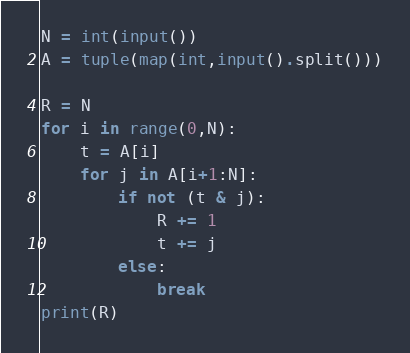Convert code to text. <code><loc_0><loc_0><loc_500><loc_500><_Python_>N = int(input())
A = tuple(map(int,input().split()))

R = N
for i in range(0,N):
    t = A[i]
    for j in A[i+1:N]:
        if not (t & j):
            R += 1
            t += j
        else:
            break
print(R)
</code> 